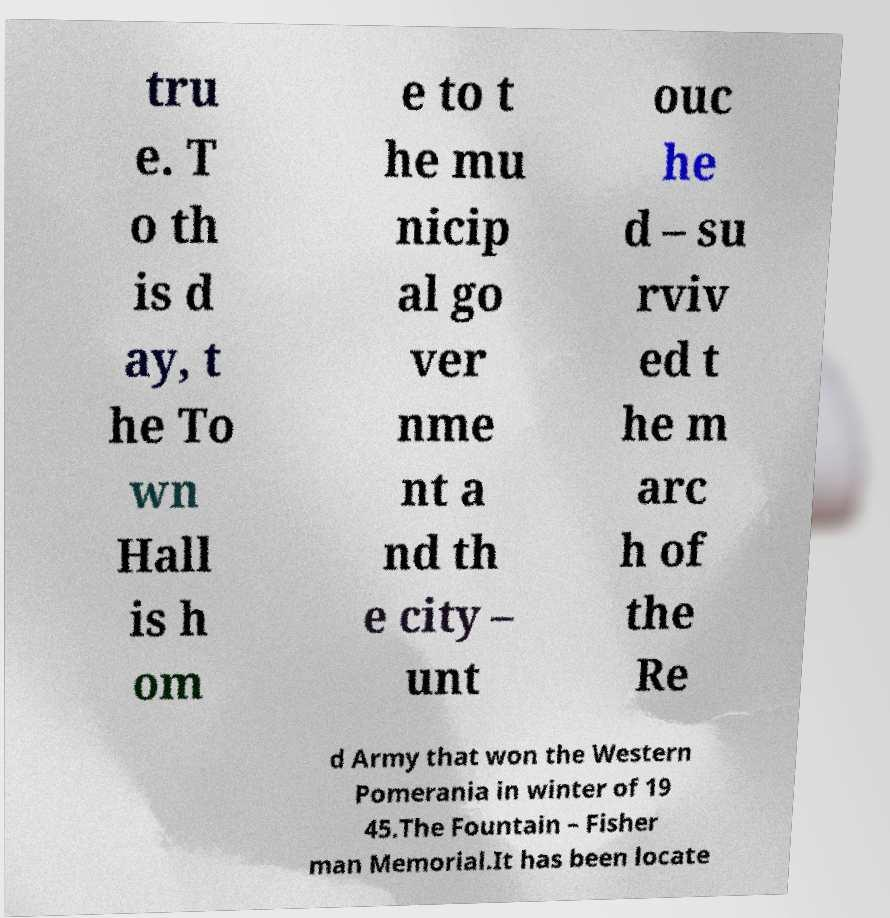What messages or text are displayed in this image? I need them in a readable, typed format. tru e. T o th is d ay, t he To wn Hall is h om e to t he mu nicip al go ver nme nt a nd th e city – unt ouc he d – su rviv ed t he m arc h of the Re d Army that won the Western Pomerania in winter of 19 45.The Fountain – Fisher man Memorial.It has been locate 